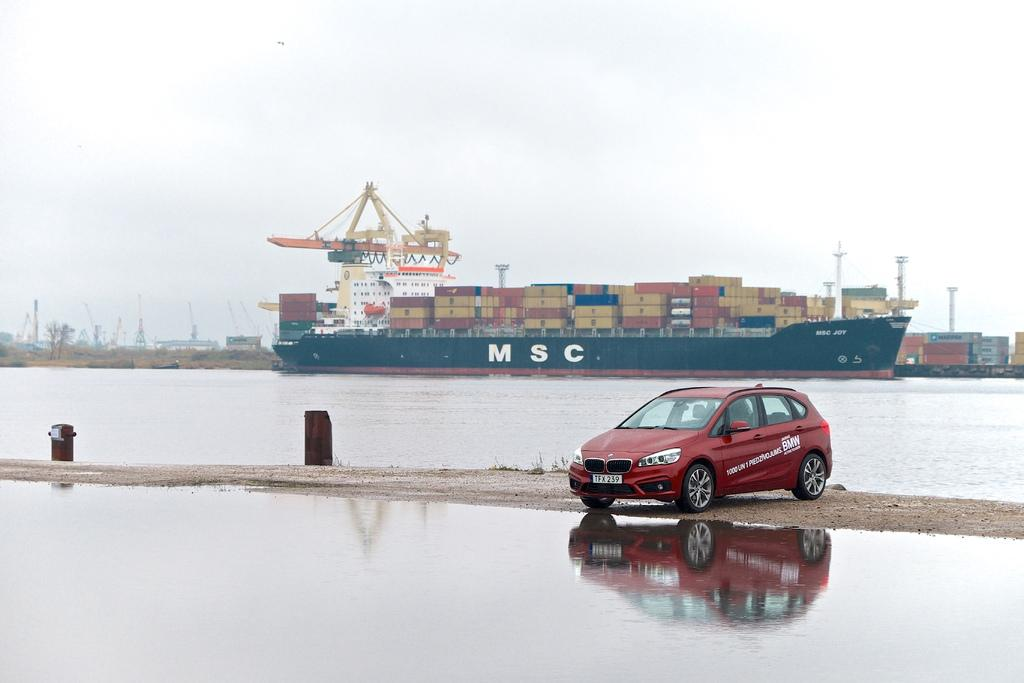What is the main subject of the image? The main subject of the image is a ship. What other mode of transportation can be seen in the image? There is a car in the image. What type of natural environment is visible in the image? Water is visible in the image. What is visible in the sky in the image? The sky is visible in the image. Can you see any fairies flying around the ship in the image? There are no fairies present in the image. Is the grandfather of the car owner visible in the image? There is no reference to a grandfather in the image. 